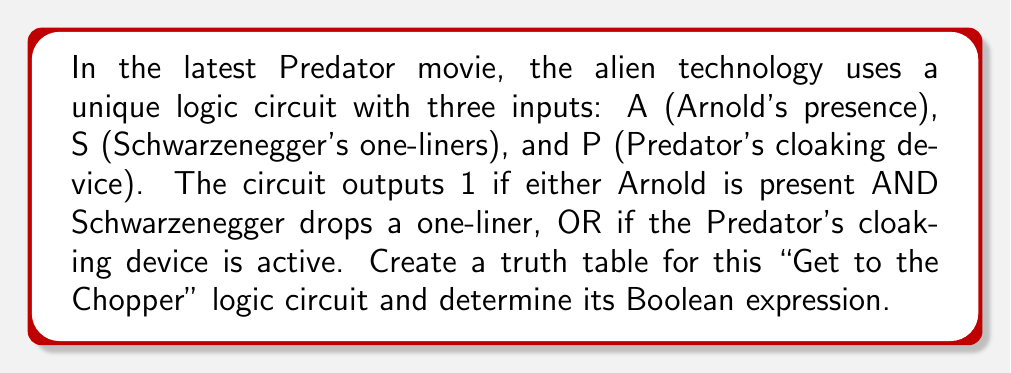Can you solve this math problem? Let's approach this step-by-step:

1) First, we need to identify the inputs and output:
   Inputs: A, S, P
   Output: Let's call it Y

2) The circuit description gives us the Boolean expression:
   $Y = (A \cdot S) + P$

3) Now, let's create the truth table. With 3 inputs, we'll have $2^3 = 8$ rows:

   | A | S | P | Y |
   |---|---|---|---|
   | 0 | 0 | 0 | 0 |
   | 0 | 0 | 1 | 1 |
   | 0 | 1 | 0 | 0 |
   | 0 | 1 | 1 | 1 |
   | 1 | 0 | 0 | 0 |
   | 1 | 0 | 1 | 1 |
   | 1 | 1 | 0 | 1 |
   | 1 | 1 | 1 | 1 |

4) Let's verify each row:
   - When P is 1, Y is always 1 (rows 2, 4, 6, 8)
   - When A and S are both 1, Y is 1 (rows 7, 8)
   - In all other cases, Y is 0

5) The Boolean expression $Y = (A \cdot S) + P$ correctly represents this truth table.
Answer: $Y = (A \cdot S) + P$ 